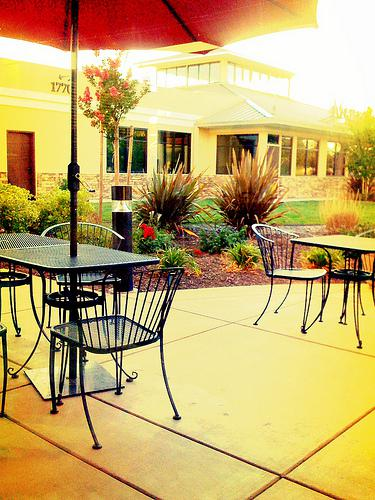Question: who is present in the photo?
Choices:
A. Two women in bikinis.
B. Two little girls in dresses.
C. Nobody.
D. Two men in suits.
Answer with the letter. Answer: C Question: what color is the umbrella?
Choices:
A. Blue.
B. Green.
C. Red.
D. Black.
Answer with the letter. Answer: C Question: where are there windows?
Choices:
A. In front of the restaurant.
B. In front of the store.
C. The taxi cab.
D. On the side of the building.
Answer with the letter. Answer: D Question: why are there chairs?
Choices:
A. Easy objects to stand on if needed.
B. So people won't have to sit in the sand.
C. For people to sit on.
D. No room for couches.
Answer with the letter. Answer: C Question: what is growing behind the patio?
Choices:
A. Weeds.
B. Rhubarb.
C. A tree and other flowering plants.
D. Moss.
Answer with the letter. Answer: C 